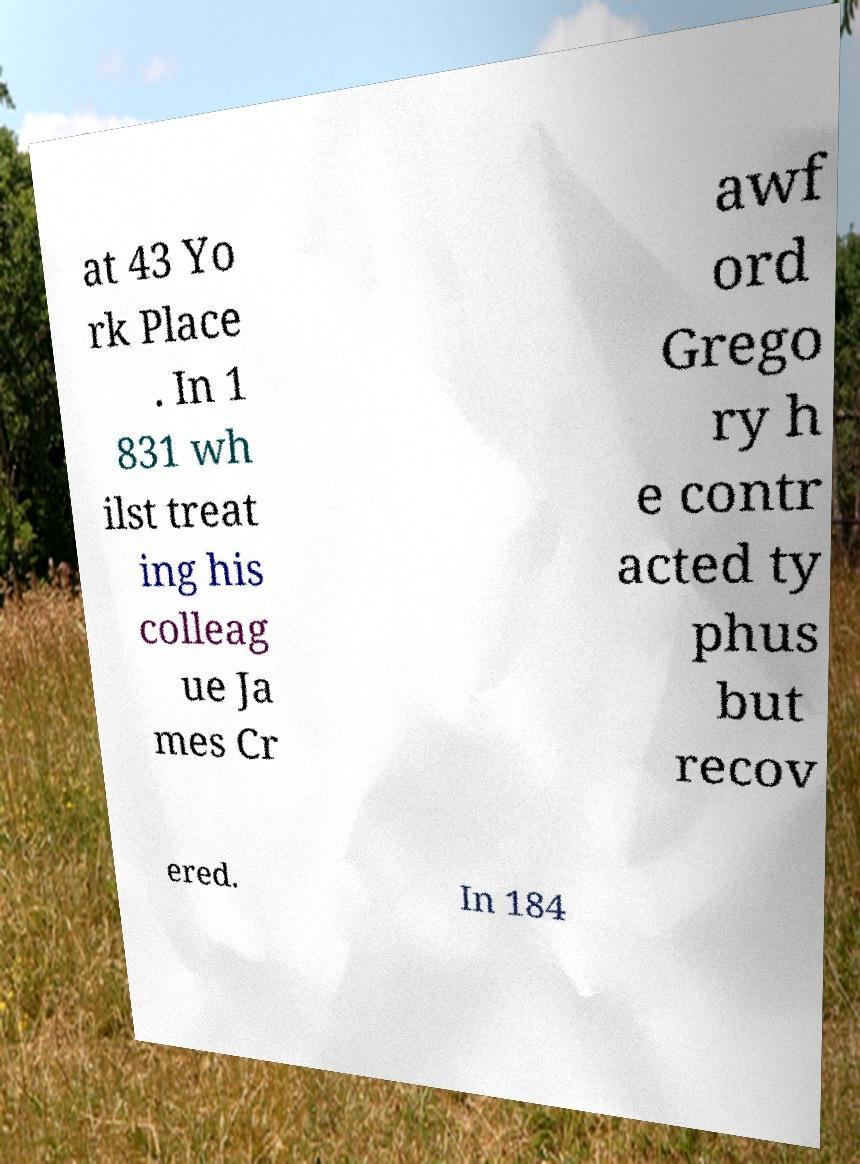Could you assist in decoding the text presented in this image and type it out clearly? at 43 Yo rk Place . In 1 831 wh ilst treat ing his colleag ue Ja mes Cr awf ord Grego ry h e contr acted ty phus but recov ered. In 184 